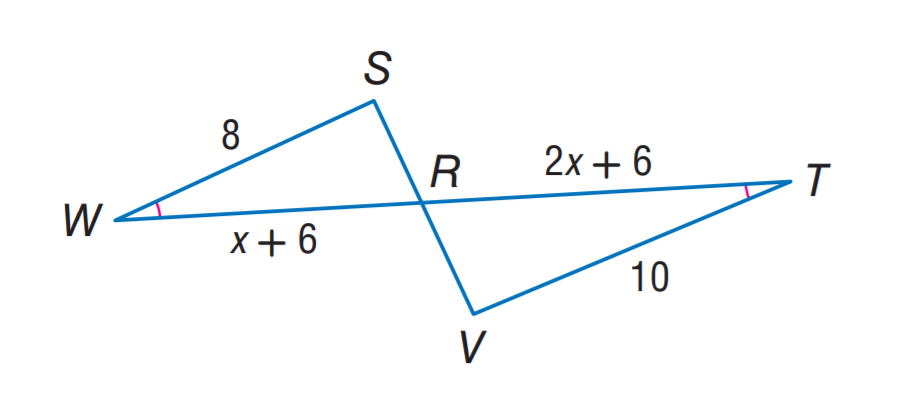Answer the mathemtical geometry problem and directly provide the correct option letter.
Question: Find R T.
Choices: A: 6 B: 8 C: 10 D: 12 C 